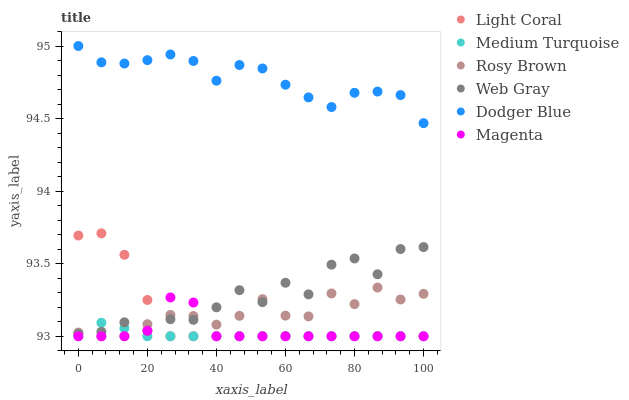Does Medium Turquoise have the minimum area under the curve?
Answer yes or no. Yes. Does Dodger Blue have the maximum area under the curve?
Answer yes or no. Yes. Does Rosy Brown have the minimum area under the curve?
Answer yes or no. No. Does Rosy Brown have the maximum area under the curve?
Answer yes or no. No. Is Medium Turquoise the smoothest?
Answer yes or no. Yes. Is Web Gray the roughest?
Answer yes or no. Yes. Is Rosy Brown the smoothest?
Answer yes or no. No. Is Rosy Brown the roughest?
Answer yes or no. No. Does Rosy Brown have the lowest value?
Answer yes or no. Yes. Does Dodger Blue have the lowest value?
Answer yes or no. No. Does Dodger Blue have the highest value?
Answer yes or no. Yes. Does Rosy Brown have the highest value?
Answer yes or no. No. Is Web Gray less than Dodger Blue?
Answer yes or no. Yes. Is Dodger Blue greater than Web Gray?
Answer yes or no. Yes. Does Rosy Brown intersect Light Coral?
Answer yes or no. Yes. Is Rosy Brown less than Light Coral?
Answer yes or no. No. Is Rosy Brown greater than Light Coral?
Answer yes or no. No. Does Web Gray intersect Dodger Blue?
Answer yes or no. No. 